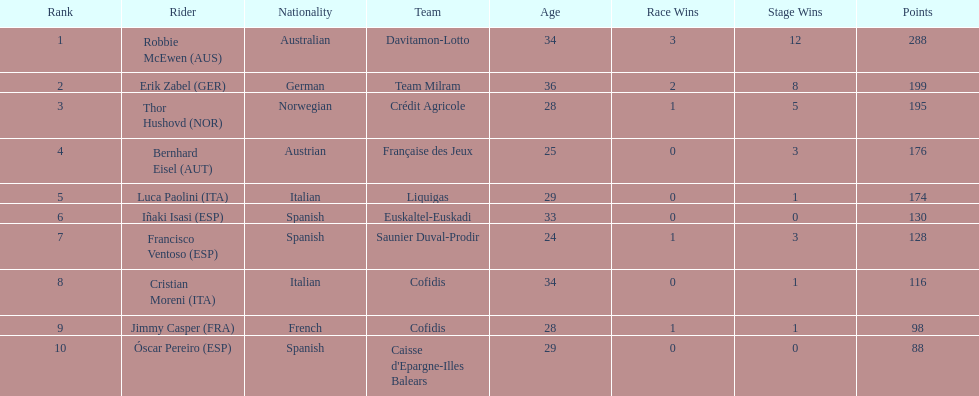How many more points did erik zabel score than franciso ventoso? 71. 